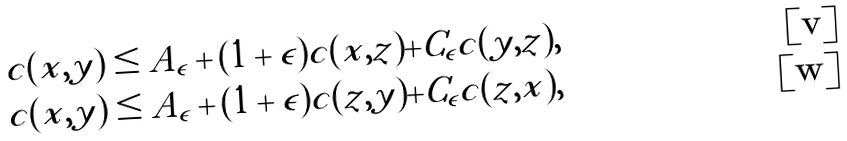<formula> <loc_0><loc_0><loc_500><loc_500>c ( x , y ) & \leq A _ { \epsilon } + ( 1 + \epsilon ) c ( x , z ) + C _ { \epsilon } c ( y , z ) , \\ c ( x , y ) & \leq A _ { \epsilon } + ( 1 + \epsilon ) c ( z , y ) + C _ { \epsilon } c ( z , x ) ,</formula> 